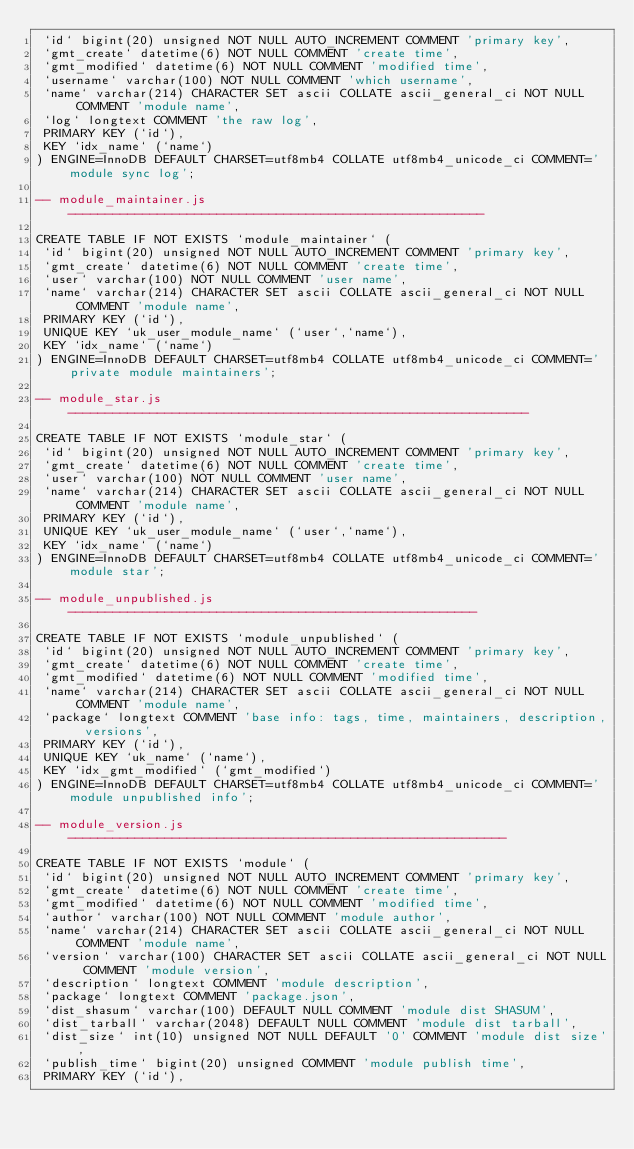<code> <loc_0><loc_0><loc_500><loc_500><_SQL_> `id` bigint(20) unsigned NOT NULL AUTO_INCREMENT COMMENT 'primary key',
 `gmt_create` datetime(6) NOT NULL COMMENT 'create time',
 `gmt_modified` datetime(6) NOT NULL COMMENT 'modified time',
 `username` varchar(100) NOT NULL COMMENT 'which username',
 `name` varchar(214) CHARACTER SET ascii COLLATE ascii_general_ci NOT NULL COMMENT 'module name',
 `log` longtext COMMENT 'the raw log',
 PRIMARY KEY (`id`),
 KEY `idx_name` (`name`)
) ENGINE=InnoDB DEFAULT CHARSET=utf8mb4 COLLATE utf8mb4_unicode_ci COMMENT='module sync log';

-- module_maintainer.js --------------------------------------------------------

CREATE TABLE IF NOT EXISTS `module_maintainer` (
 `id` bigint(20) unsigned NOT NULL AUTO_INCREMENT COMMENT 'primary key',
 `gmt_create` datetime(6) NOT NULL COMMENT 'create time',
 `user` varchar(100) NOT NULL COMMENT 'user name',
 `name` varchar(214) CHARACTER SET ascii COLLATE ascii_general_ci NOT NULL COMMENT 'module name',
 PRIMARY KEY (`id`),
 UNIQUE KEY `uk_user_module_name` (`user`,`name`),
 KEY `idx_name` (`name`)
) ENGINE=InnoDB DEFAULT CHARSET=utf8mb4 COLLATE utf8mb4_unicode_ci COMMENT='private module maintainers';

-- module_star.js --------------------------------------------------------------

CREATE TABLE IF NOT EXISTS `module_star` (
 `id` bigint(20) unsigned NOT NULL AUTO_INCREMENT COMMENT 'primary key',
 `gmt_create` datetime(6) NOT NULL COMMENT 'create time',
 `user` varchar(100) NOT NULL COMMENT 'user name',
 `name` varchar(214) CHARACTER SET ascii COLLATE ascii_general_ci NOT NULL COMMENT 'module name',
 PRIMARY KEY (`id`),
 UNIQUE KEY `uk_user_module_name` (`user`,`name`),
 KEY `idx_name` (`name`)
) ENGINE=InnoDB DEFAULT CHARSET=utf8mb4 COLLATE utf8mb4_unicode_ci COMMENT='module star';

-- module_unpublished.js -------------------------------------------------------

CREATE TABLE IF NOT EXISTS `module_unpublished` (
 `id` bigint(20) unsigned NOT NULL AUTO_INCREMENT COMMENT 'primary key',
 `gmt_create` datetime(6) NOT NULL COMMENT 'create time',
 `gmt_modified` datetime(6) NOT NULL COMMENT 'modified time',
 `name` varchar(214) CHARACTER SET ascii COLLATE ascii_general_ci NOT NULL COMMENT 'module name',
 `package` longtext COMMENT 'base info: tags, time, maintainers, description, versions',
 PRIMARY KEY (`id`),
 UNIQUE KEY `uk_name` (`name`),
 KEY `idx_gmt_modified` (`gmt_modified`)
) ENGINE=InnoDB DEFAULT CHARSET=utf8mb4 COLLATE utf8mb4_unicode_ci COMMENT='module unpublished info';

-- module_version.js -----------------------------------------------------------

CREATE TABLE IF NOT EXISTS `module` (
 `id` bigint(20) unsigned NOT NULL AUTO_INCREMENT COMMENT 'primary key',
 `gmt_create` datetime(6) NOT NULL COMMENT 'create time',
 `gmt_modified` datetime(6) NOT NULL COMMENT 'modified time',
 `author` varchar(100) NOT NULL COMMENT 'module author',
 `name` varchar(214) CHARACTER SET ascii COLLATE ascii_general_ci NOT NULL COMMENT 'module name',
 `version` varchar(100) CHARACTER SET ascii COLLATE ascii_general_ci NOT NULL COMMENT 'module version',
 `description` longtext COMMENT 'module description',
 `package` longtext COMMENT 'package.json',
 `dist_shasum` varchar(100) DEFAULT NULL COMMENT 'module dist SHASUM',
 `dist_tarball` varchar(2048) DEFAULT NULL COMMENT 'module dist tarball',
 `dist_size` int(10) unsigned NOT NULL DEFAULT '0' COMMENT 'module dist size',
 `publish_time` bigint(20) unsigned COMMENT 'module publish time',
 PRIMARY KEY (`id`),</code> 